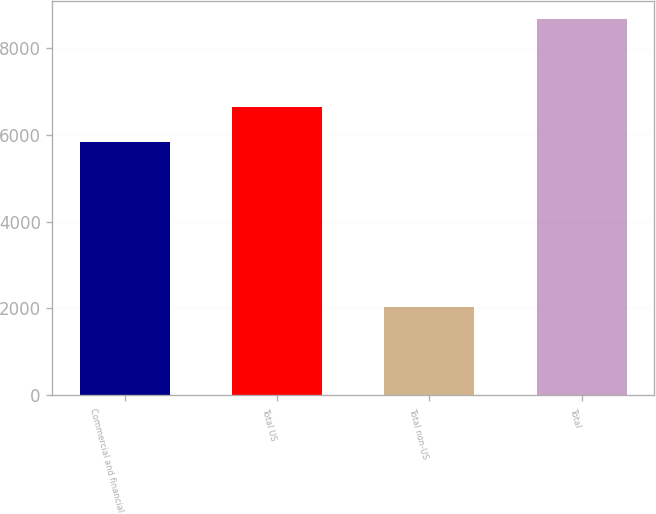Convert chart. <chart><loc_0><loc_0><loc_500><loc_500><bar_chart><fcel>Commercial and financial<fcel>Total US<fcel>Total non-US<fcel>Total<nl><fcel>5844<fcel>6630<fcel>2032<fcel>8662<nl></chart> 